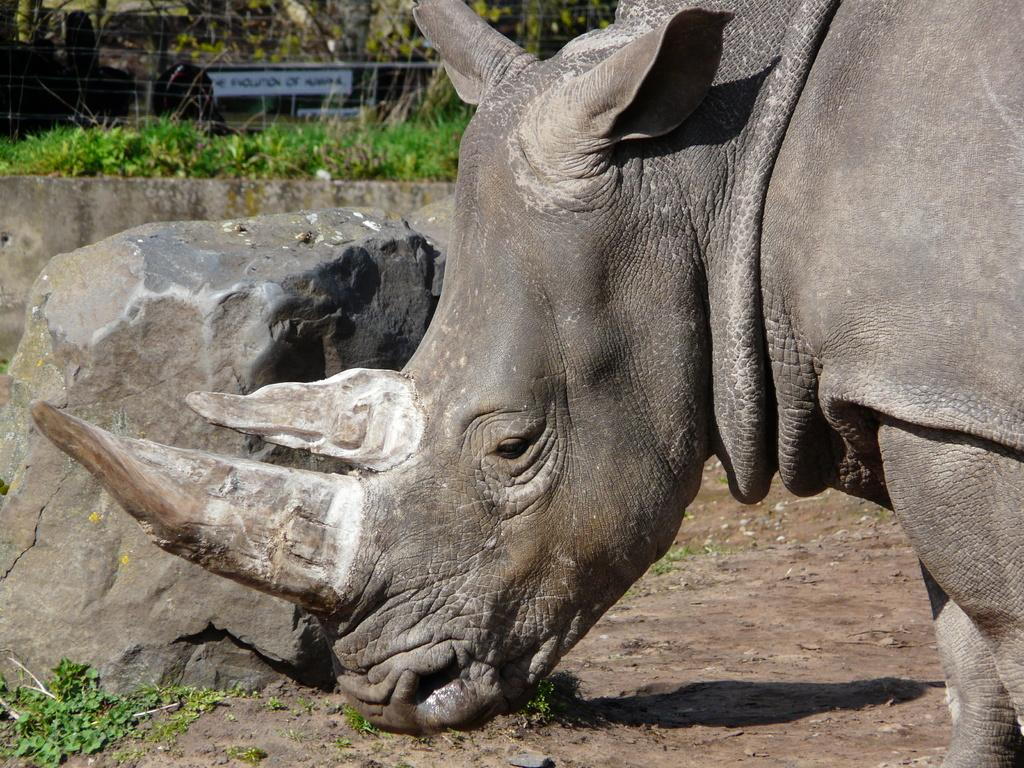What animal is the main subject of the image? There is a rhinoceros in the image. What object can be seen on the left side of the image? There is a stone on the left side of the image. What type of vegetation is visible in the background of the image? There are plants and trees in the background of the image. What feature is visible in the background of the image that might indicate a boundary or limit? There is a boundary visible in the background of the image. What type of spring is visible in the image? There is no spring present in the image; it features a rhinoceros, a stone, and vegetation in the background. What territory does the rhinoceros claim in the image? The image does not indicate any specific territory claimed by the rhinoceros. 